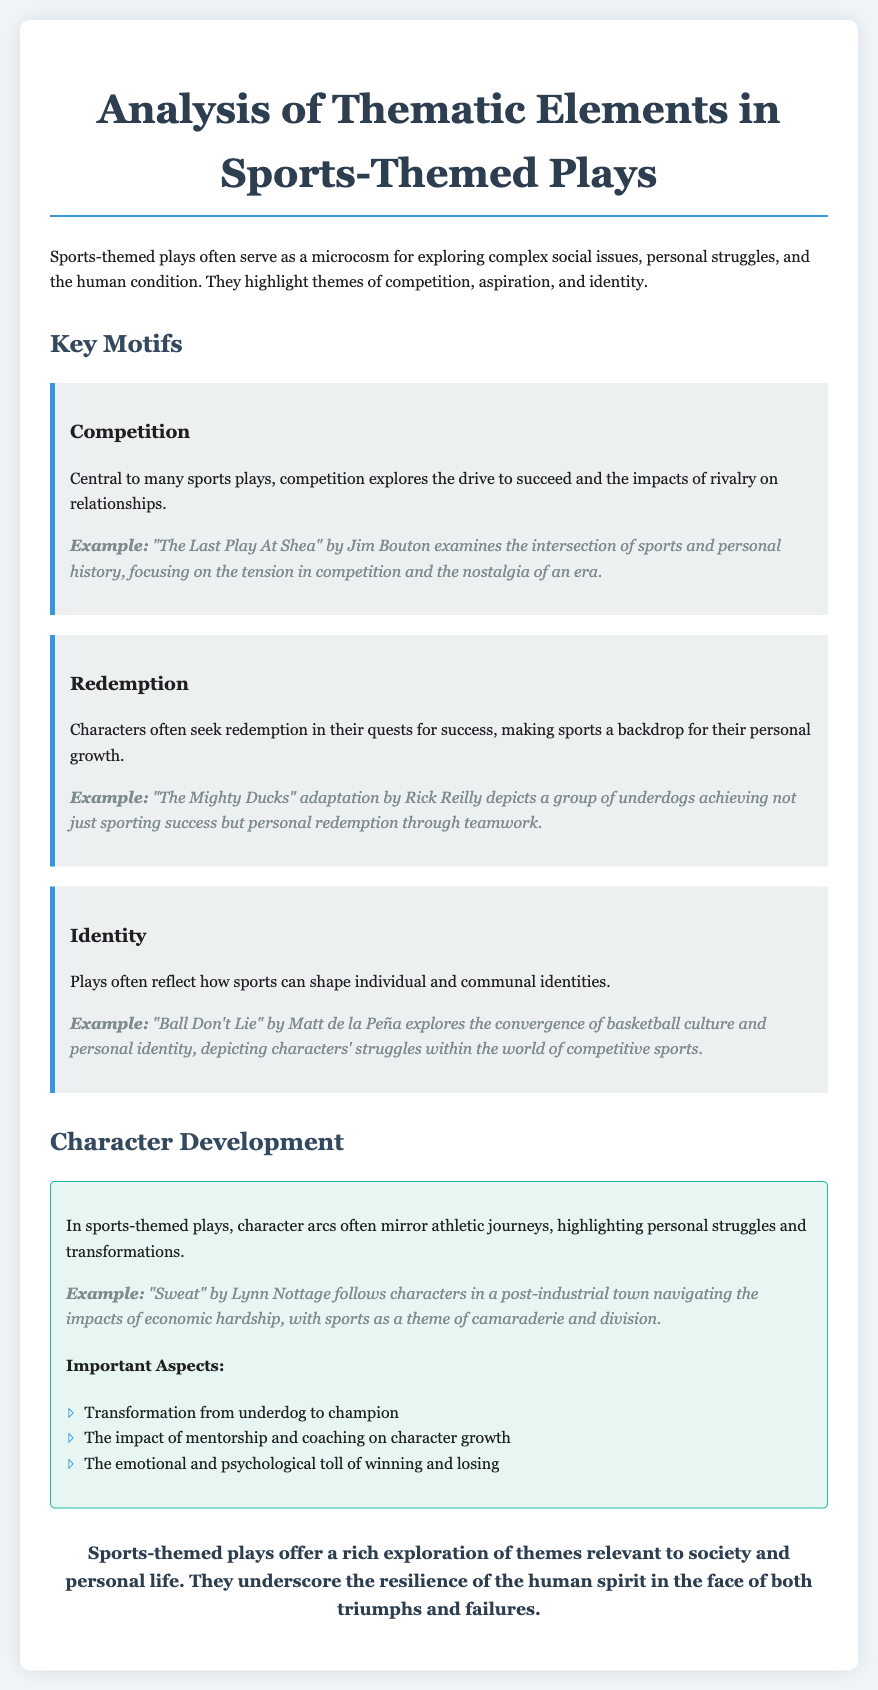what is the title of the document? The title is provided in the header of the document, indicating the thematic focus of the analysis.
Answer: Analysis of Thematic Elements in Sports-Themed Plays who is the author of "The Mighty Ducks" adaptation mentioned in the document? The document attributes the adaptation to Rick Reilly, which reveals the adaptation's focus on personal redemption through teamwork.
Answer: Rick Reilly how many key motifs are mentioned in the document? The document discusses three specific key motifs relevant to sports-themed plays, highlighting diverse themes.
Answer: three which play explores the intersection of sports and personal history? The document cites "The Last Play At Shea" as an example focused on competition and nostalgia linked to personal history.
Answer: The Last Play At Shea what important aspect relates to mentorship in character development? The document specifies that the impact of mentorship and coaching is crucial for character growth in sports-themed plays.
Answer: The impact of mentorship what theme is central to the character arcs in sports-themed plays? The document states that character arcs often reflect athletic journeys that reveal personal struggles and transformations.
Answer: athletic journeys which play illustrates the theme of camaraderie and division in a post-industrial context? The document references "Sweat" by Lynn Nottage as addressing economic hardship through sports themes.
Answer: Sweat what color is used for the background of the document? The document mentions a soft background color that enhances readability and visual appeal.
Answer: #f0f5f9 